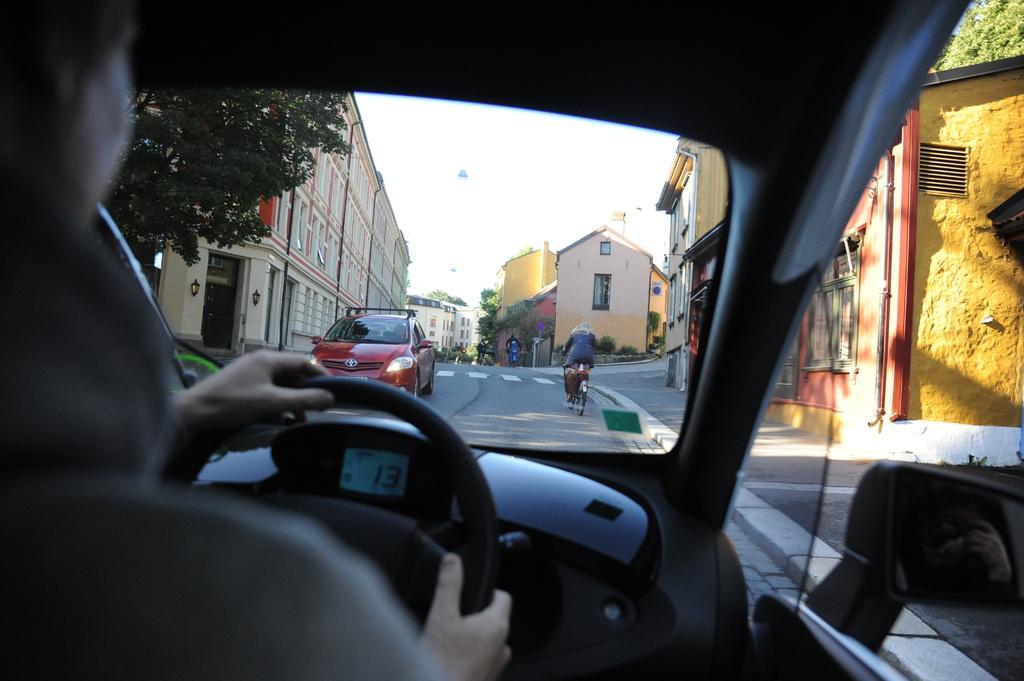In one or two sentences, can you explain what this image depicts? In the picture vehicles and bicycles on the road. I can also see a person is sitting in a vehicle. In the background I can see trees, buildings, the sky and some other things. 